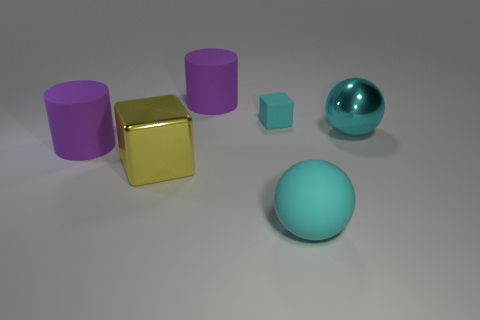Add 1 purple matte cylinders. How many objects exist? 7 Subtract all blocks. How many objects are left? 4 Subtract 1 yellow cubes. How many objects are left? 5 Subtract all big objects. Subtract all yellow cubes. How many objects are left? 0 Add 6 big rubber objects. How many big rubber objects are left? 9 Add 6 big cyan cubes. How many big cyan cubes exist? 6 